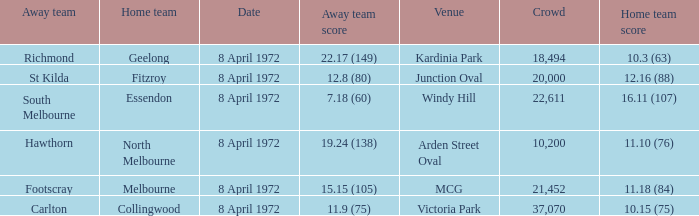Which Home team score has a Home team of geelong? 10.3 (63). 